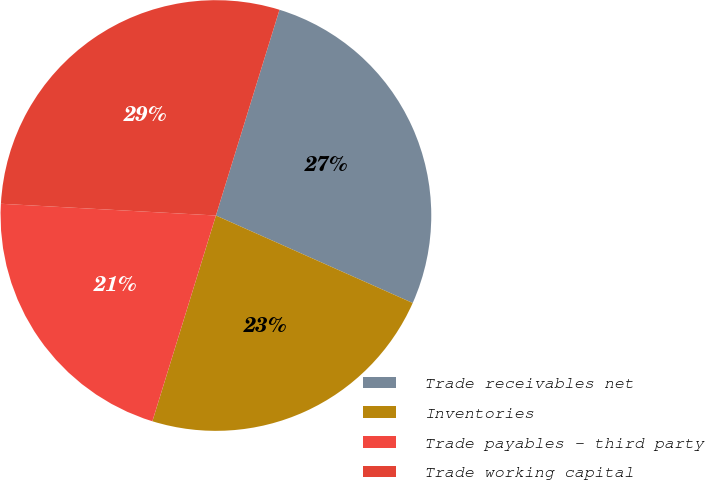Convert chart. <chart><loc_0><loc_0><loc_500><loc_500><pie_chart><fcel>Trade receivables net<fcel>Inventories<fcel>Trade payables - third party<fcel>Trade working capital<nl><fcel>26.89%<fcel>23.11%<fcel>21.1%<fcel>28.9%<nl></chart> 